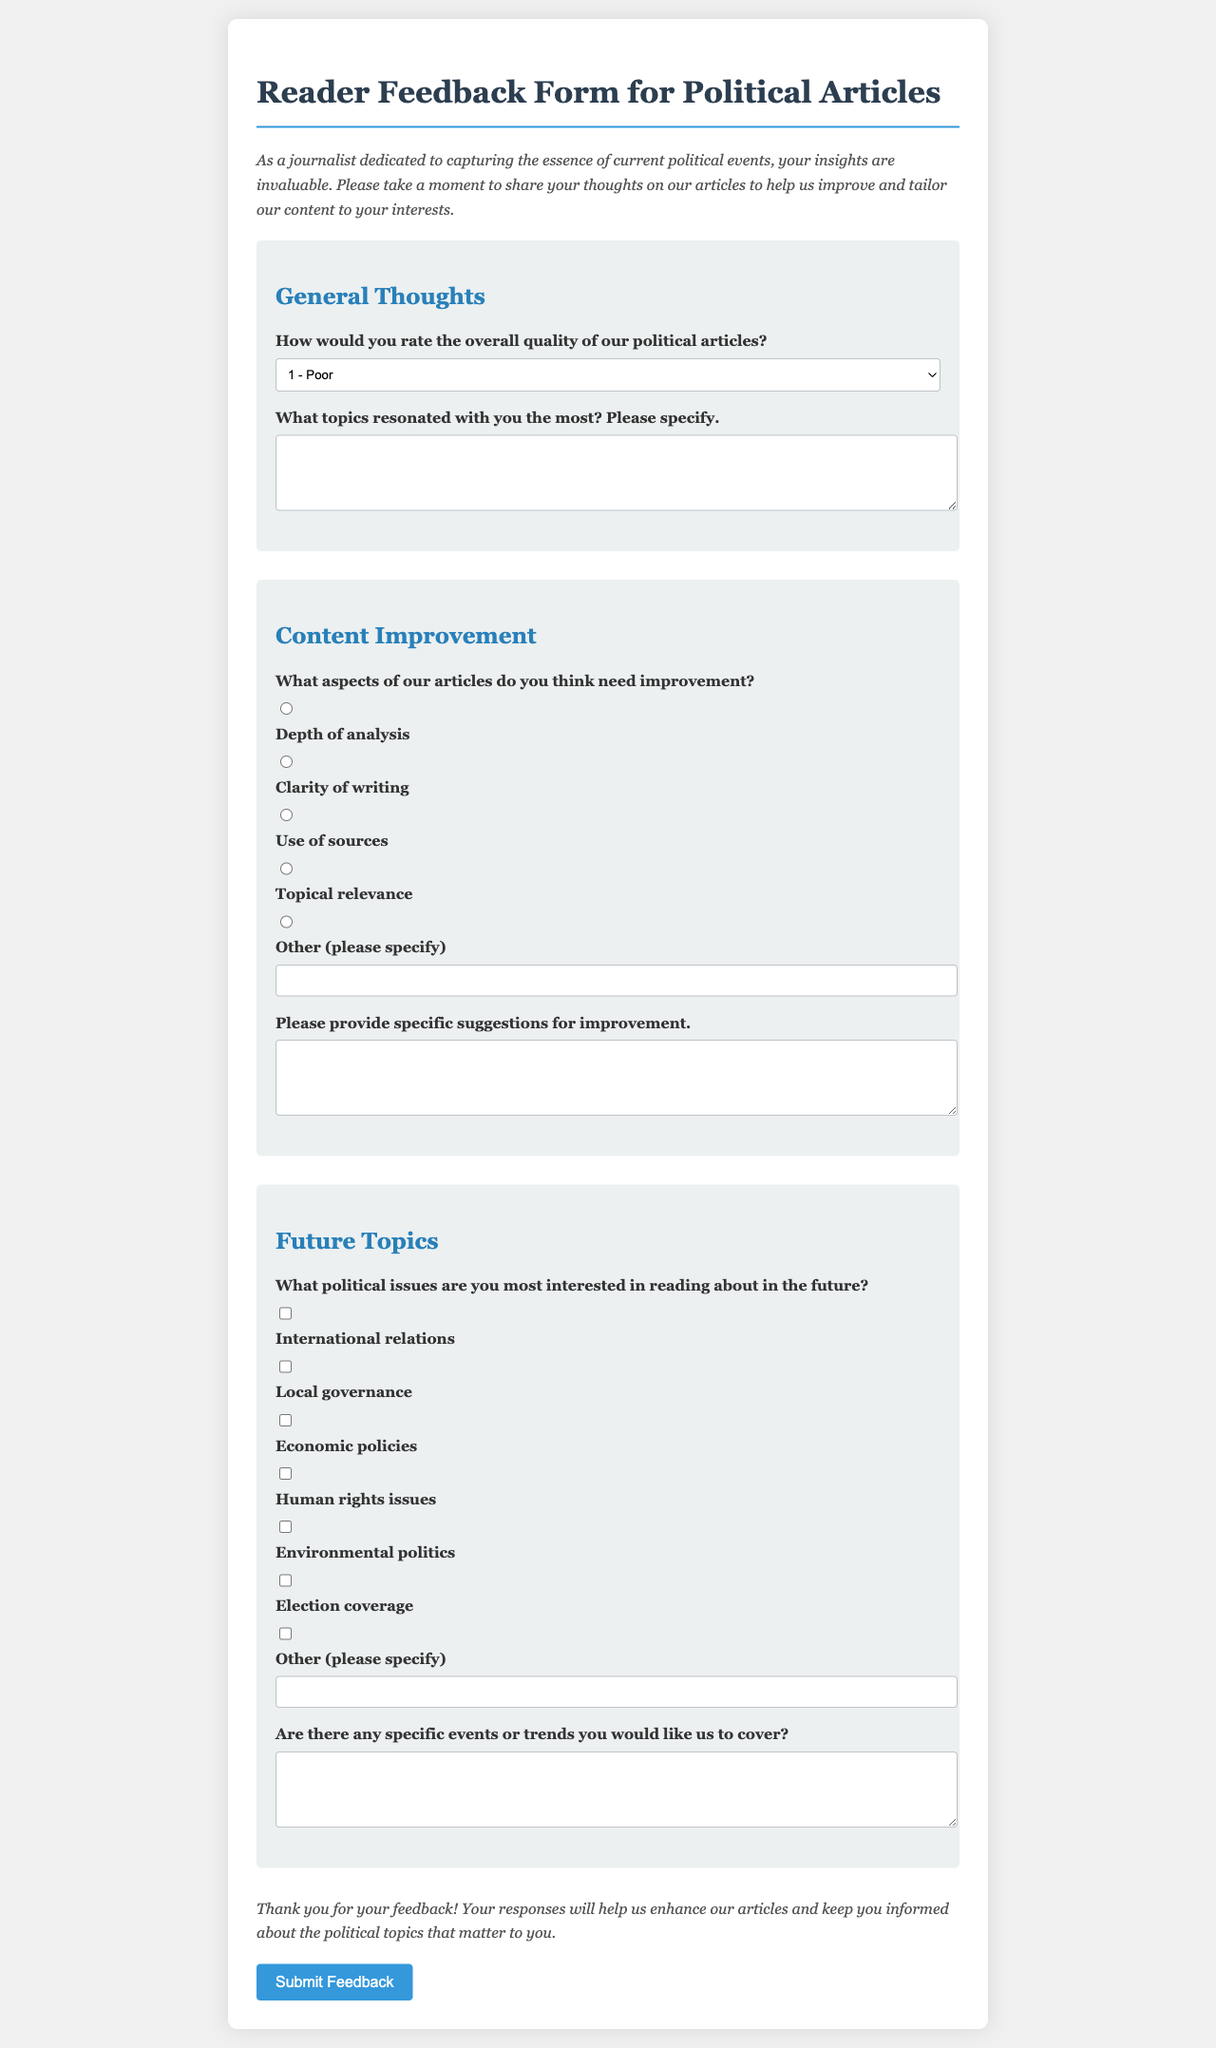how many sections are in the feedback form? The feedback form contains three main sections: General Thoughts, Content Improvement, and Future Topics.
Answer: 3 what is the maximum score for rating the quality of political articles? The quality rating is scored from 1 to 5, with 5 being the highest score.
Answer: 5 what type of suggestions are requested from readers for improvement? Readers are asked to provide specific suggestions for improvement regarding the articles.
Answer: specific suggestions what are the possible improvement aspects listed in the form? The form lists depth of analysis, clarity of writing, use of sources, topical relevance, and options for other suggestions.
Answer: depth of analysis, clarity of writing, use of sources, topical relevance what specific political issues can readers express interest in? Readers can express interest in international relations, local governance, economic policies, human rights issues, environmental politics, and election coverage.
Answer: international relations, local governance, economic policies, human rights issues, environmental politics, election coverage 